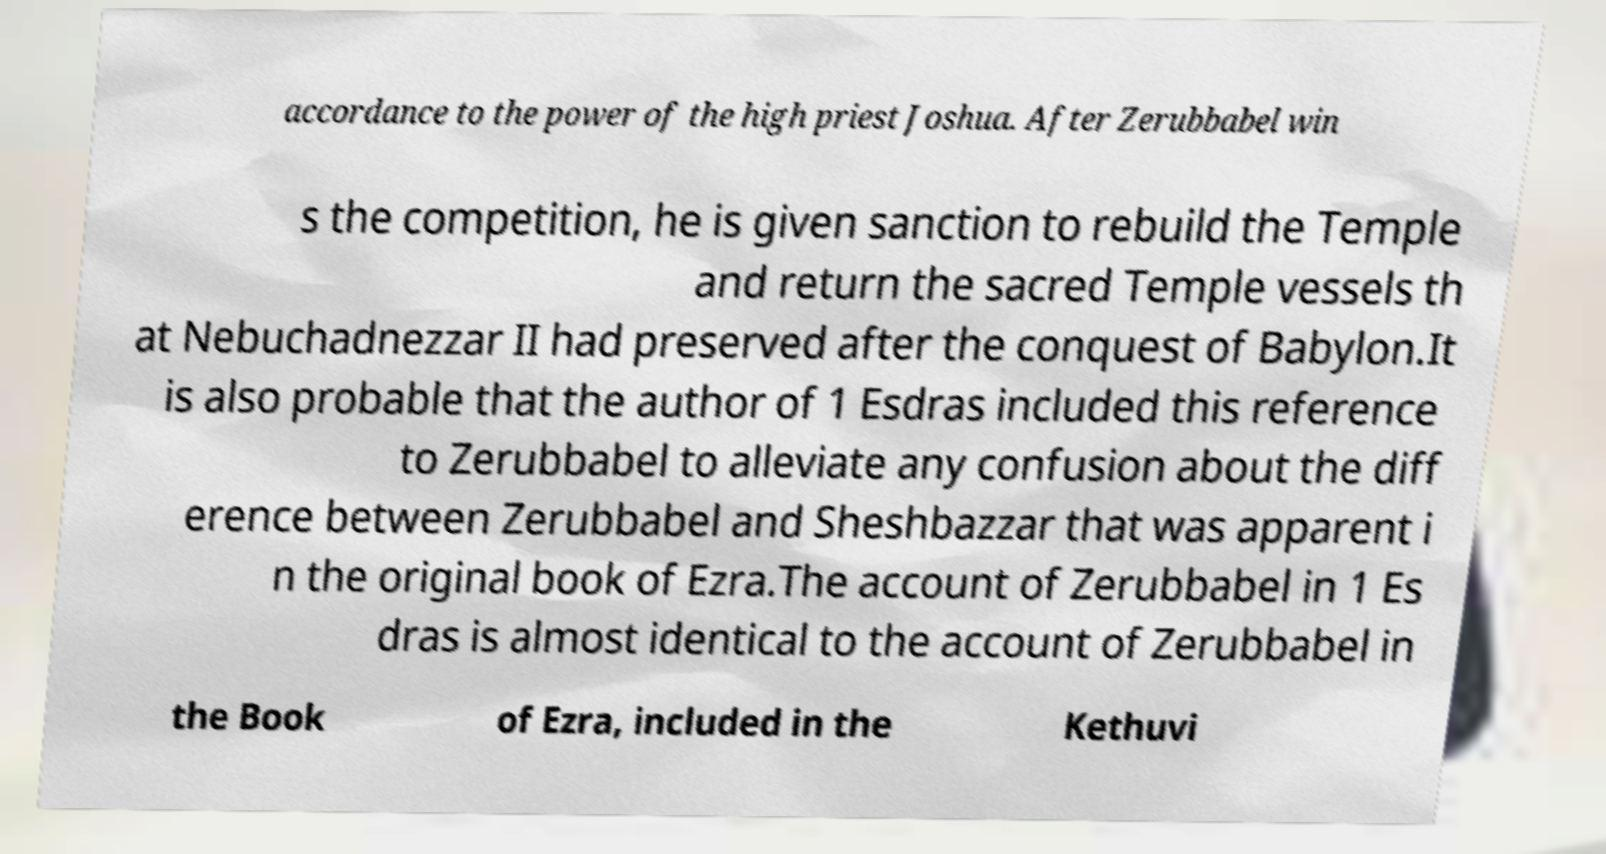For documentation purposes, I need the text within this image transcribed. Could you provide that? accordance to the power of the high priest Joshua. After Zerubbabel win s the competition, he is given sanction to rebuild the Temple and return the sacred Temple vessels th at Nebuchadnezzar II had preserved after the conquest of Babylon.It is also probable that the author of 1 Esdras included this reference to Zerubbabel to alleviate any confusion about the diff erence between Zerubbabel and Sheshbazzar that was apparent i n the original book of Ezra.The account of Zerubbabel in 1 Es dras is almost identical to the account of Zerubbabel in the Book of Ezra, included in the Kethuvi 